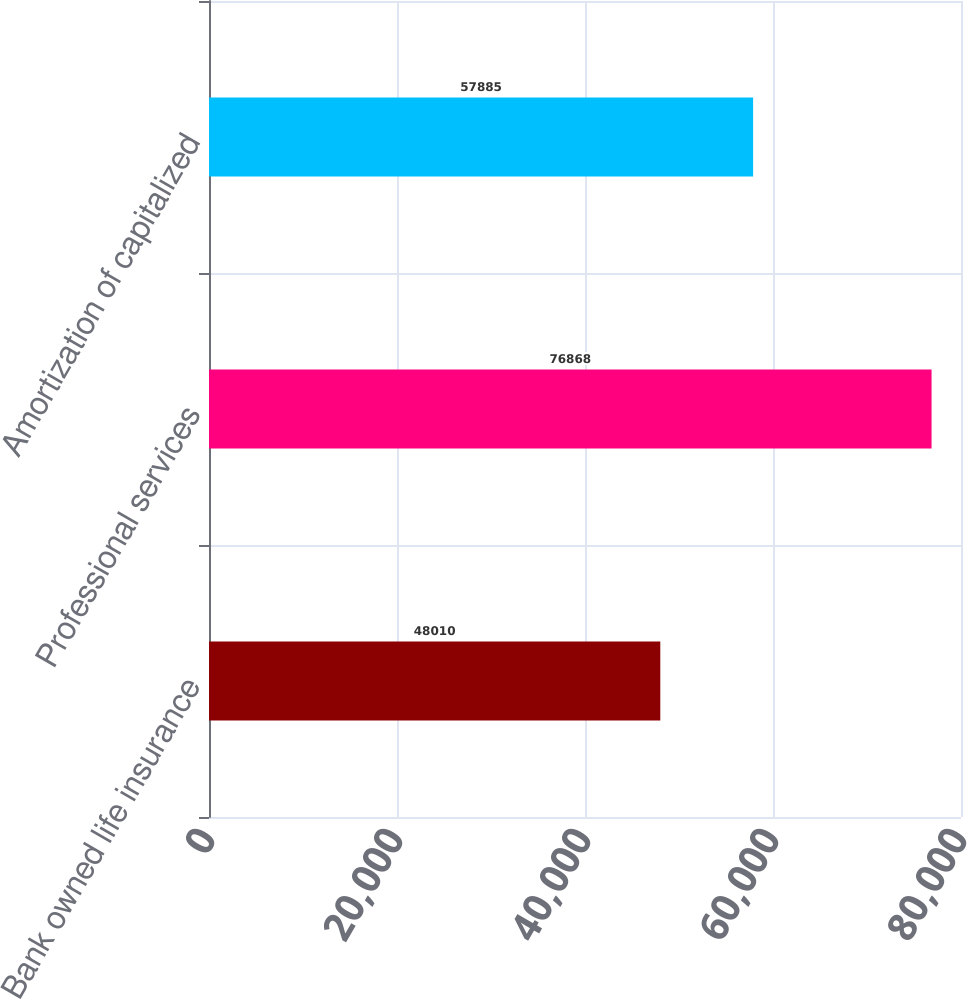Convert chart. <chart><loc_0><loc_0><loc_500><loc_500><bar_chart><fcel>Bank owned life insurance<fcel>Professional services<fcel>Amortization of capitalized<nl><fcel>48010<fcel>76868<fcel>57885<nl></chart> 